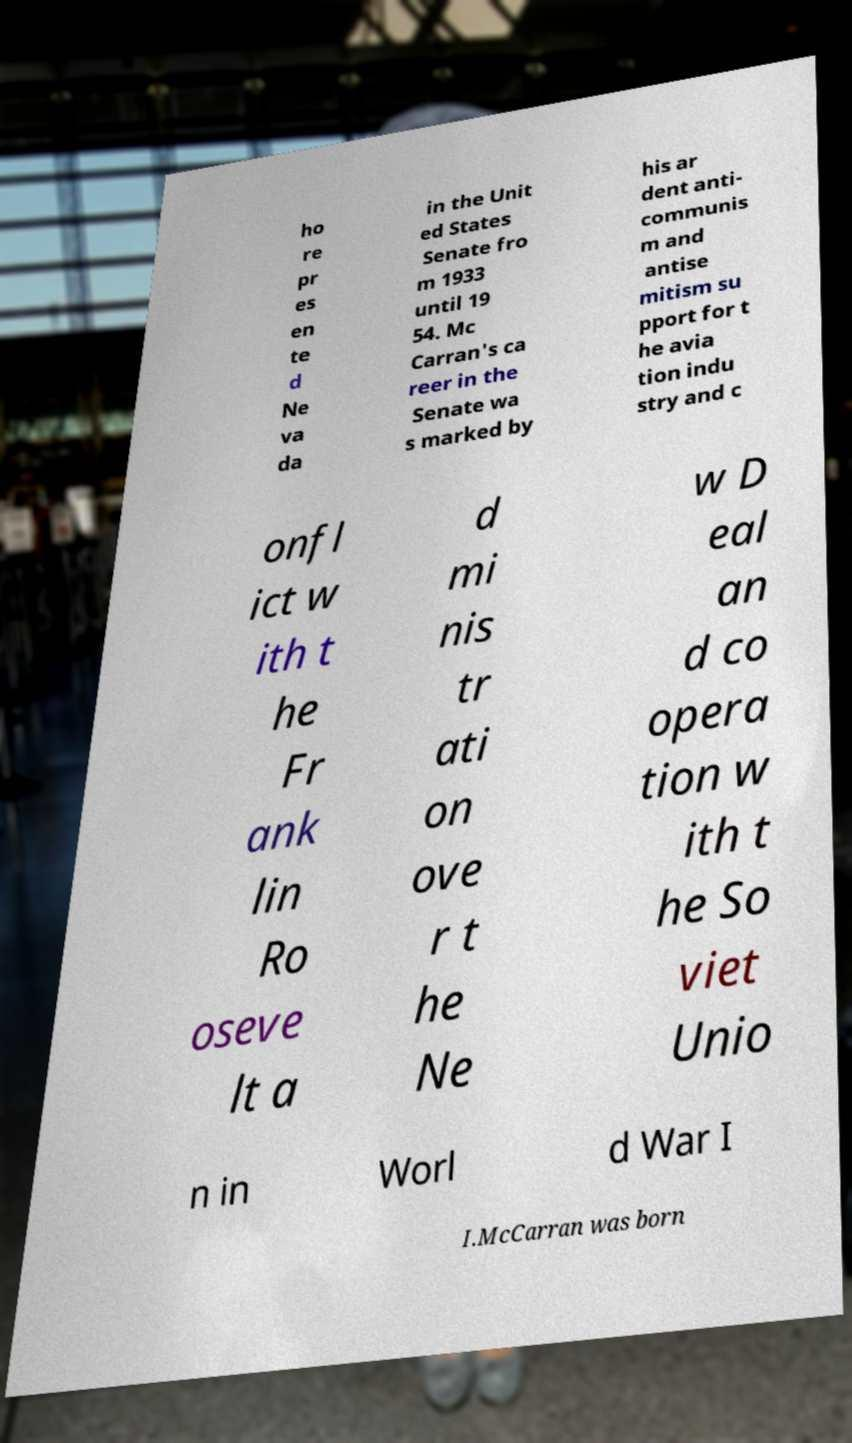For documentation purposes, I need the text within this image transcribed. Could you provide that? ho re pr es en te d Ne va da in the Unit ed States Senate fro m 1933 until 19 54. Mc Carran's ca reer in the Senate wa s marked by his ar dent anti- communis m and antise mitism su pport for t he avia tion indu stry and c onfl ict w ith t he Fr ank lin Ro oseve lt a d mi nis tr ati on ove r t he Ne w D eal an d co opera tion w ith t he So viet Unio n in Worl d War I I.McCarran was born 